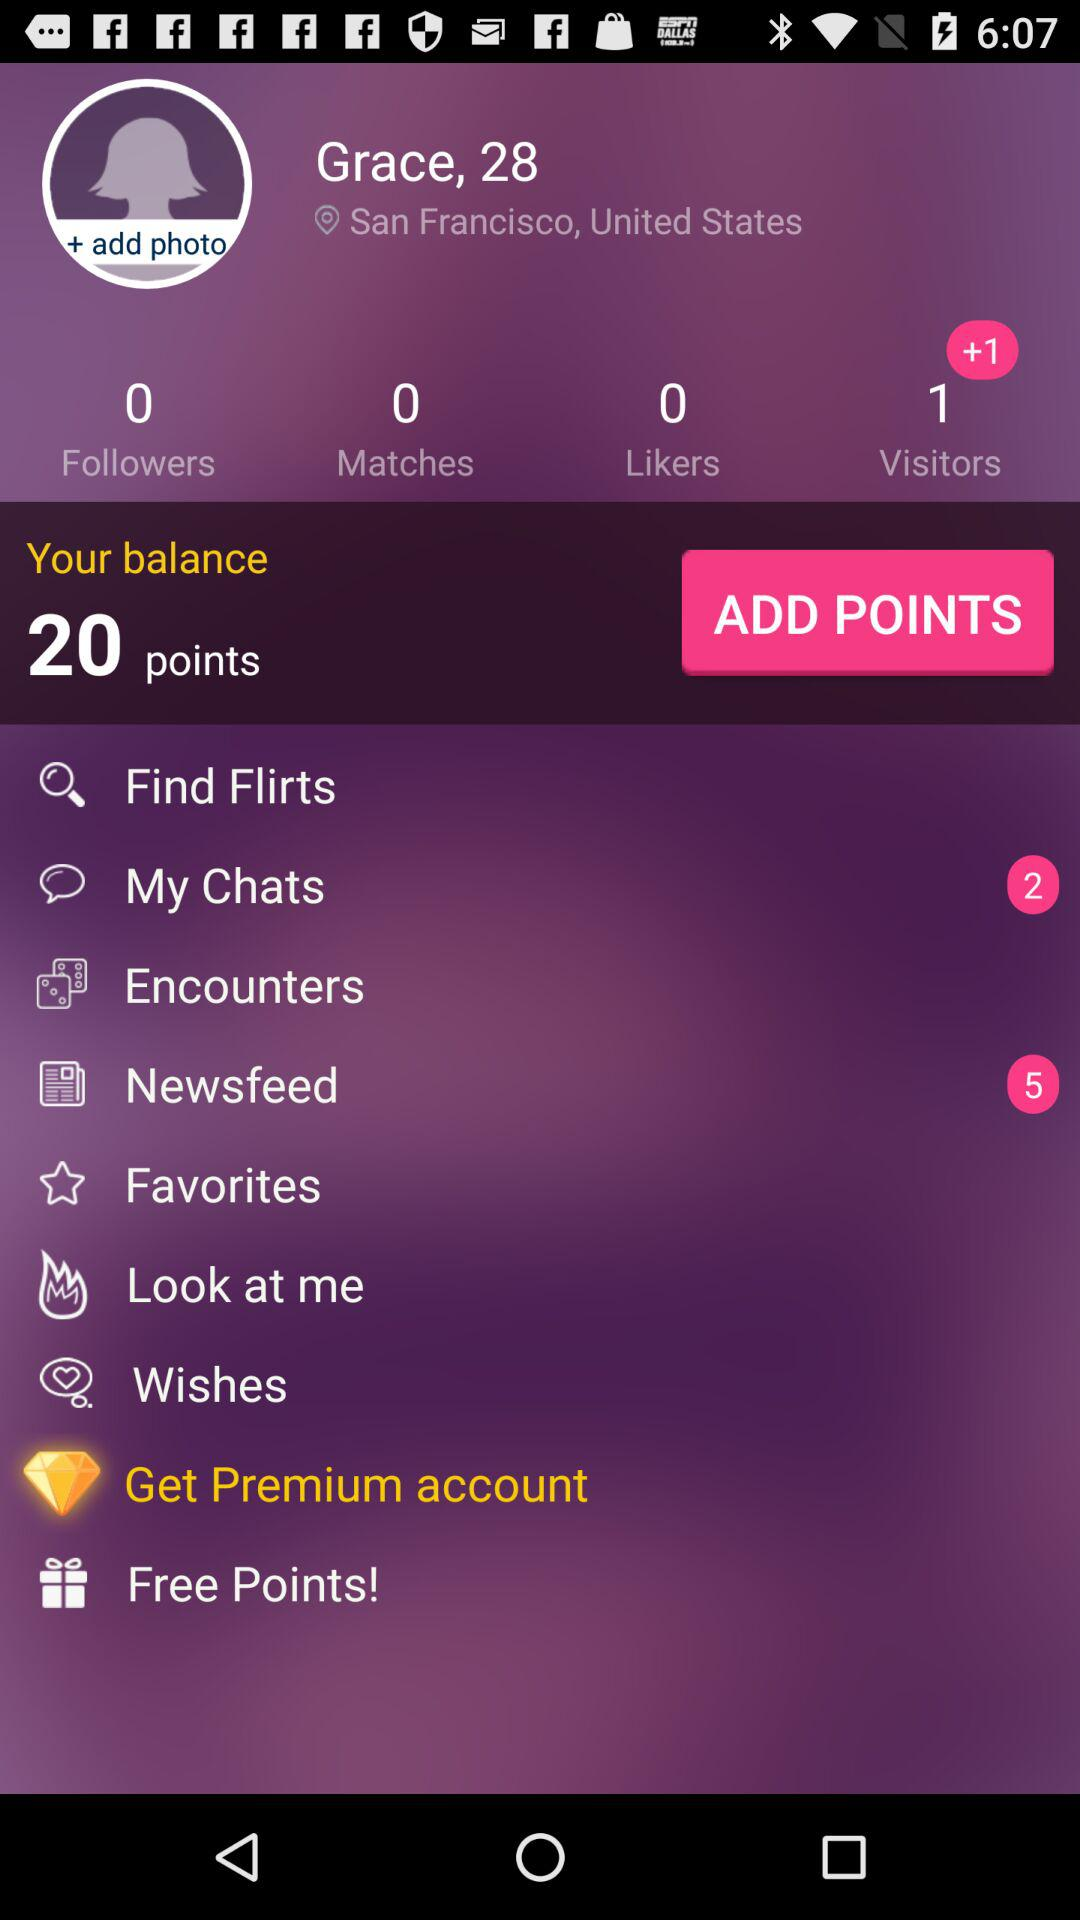How many notifications are there for the newsfeed? There are 5 notifications for the newsfeed. 